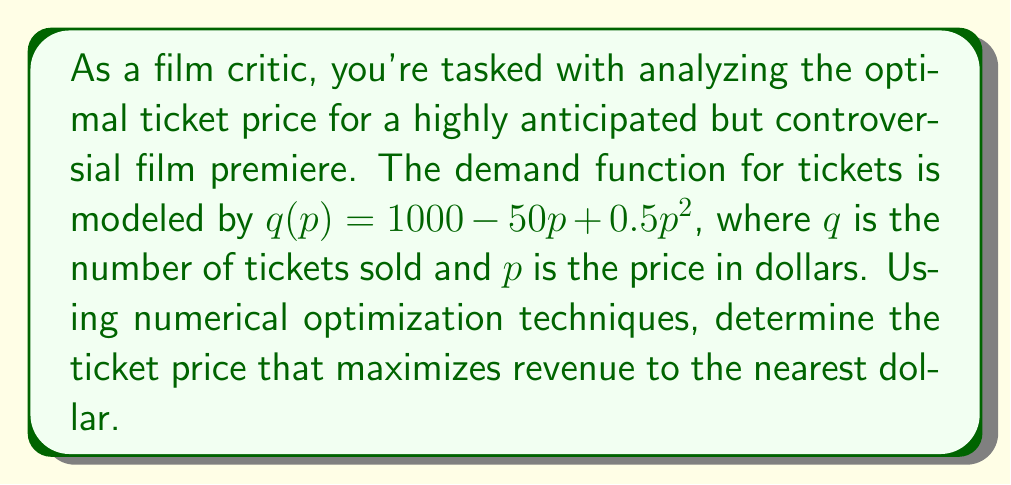Give your solution to this math problem. To solve this problem, we'll use the following steps:

1) The revenue function $R(p)$ is given by price times quantity:
   $R(p) = p \cdot q(p) = p(1000 - 50p + 0.5p^2)$

2) Expand this:
   $R(p) = 1000p - 50p^2 + 0.5p^3$

3) To maximize revenue, we need to find where $\frac{dR}{dp} = 0$:
   $\frac{dR}{dp} = 1000 - 100p + 1.5p^2$

4) Setting this equal to zero:
   $1000 - 100p + 1.5p^2 = 0$

5) This is a quadratic equation that's difficult to solve analytically. We'll use the Newton-Raphson method to find the root numerically.

6) The Newton-Raphson formula is:
   $p_{n+1} = p_n - \frac{f(p_n)}{f'(p_n)}$

   Where $f(p) = 1000 - 100p + 1.5p^2$ and $f'(p) = -100 + 3p$

7) Start with an initial guess, say $p_0 = 20$:

   $p_1 = 20 - \frac{1000 - 100(20) + 1.5(20)^2}{-100 + 3(20)} = 22.73$

   $p_2 = 22.73 - \frac{1000 - 100(22.73) + 1.5(22.73)^2}{-100 + 3(22.73)} = 23.33$

   $p_3 = 23.33 - \frac{1000 - 100(23.33) + 1.5(23.33)^2}{-100 + 3(23.33)} = 23.39$

8) The solution converges to approximately 23.39.

9) To verify this is a maximum, we can check the second derivative is negative:
   $\frac{d^2R}{dp^2} = -100 + 3p = -100 + 3(23.39) = -29.83 < 0$

Therefore, the optimal price to the nearest dollar is $23.
Answer: $23 